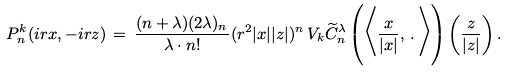Convert formula to latex. <formula><loc_0><loc_0><loc_500><loc_500>P _ { n } ^ { k } ( i r x , - i r z ) \, = \, \frac { ( n + \lambda ) ( 2 \lambda ) _ { n } } { \lambda \cdot n ! } ( r ^ { 2 } | x | | z | ) ^ { n } \, V _ { k } \widetilde { C } _ { n } ^ { \lambda } \left ( \Big < \frac { x } { | x | } , \, . \, \Big > \right ) \left ( \frac { z } { | z | } \right ) .</formula> 